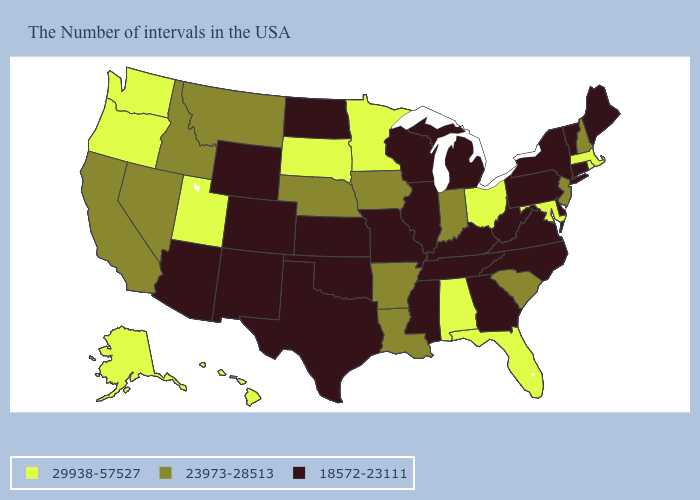What is the value of Iowa?
Give a very brief answer. 23973-28513. What is the lowest value in the USA?
Keep it brief. 18572-23111. What is the value of Georgia?
Be succinct. 18572-23111. What is the value of Vermont?
Answer briefly. 18572-23111. What is the value of Oregon?
Be succinct. 29938-57527. What is the value of Iowa?
Concise answer only. 23973-28513. What is the lowest value in the USA?
Be succinct. 18572-23111. Name the states that have a value in the range 23973-28513?
Short answer required. New Hampshire, New Jersey, South Carolina, Indiana, Louisiana, Arkansas, Iowa, Nebraska, Montana, Idaho, Nevada, California. Does New Mexico have the same value as Colorado?
Be succinct. Yes. What is the highest value in the West ?
Answer briefly. 29938-57527. Does Florida have the lowest value in the South?
Give a very brief answer. No. Among the states that border New Hampshire , which have the highest value?
Keep it brief. Massachusetts. What is the value of South Carolina?
Short answer required. 23973-28513. Name the states that have a value in the range 23973-28513?
Quick response, please. New Hampshire, New Jersey, South Carolina, Indiana, Louisiana, Arkansas, Iowa, Nebraska, Montana, Idaho, Nevada, California. Among the states that border Arkansas , does Tennessee have the lowest value?
Quick response, please. Yes. 